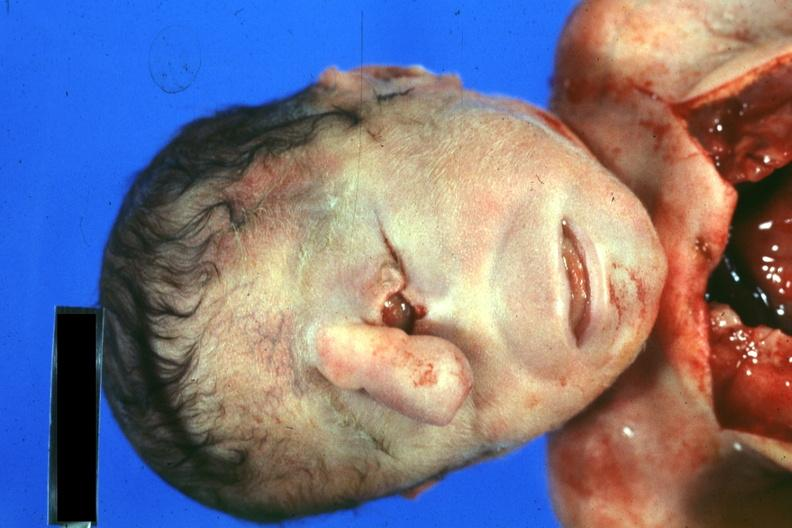what is present?
Answer the question using a single word or phrase. Face 